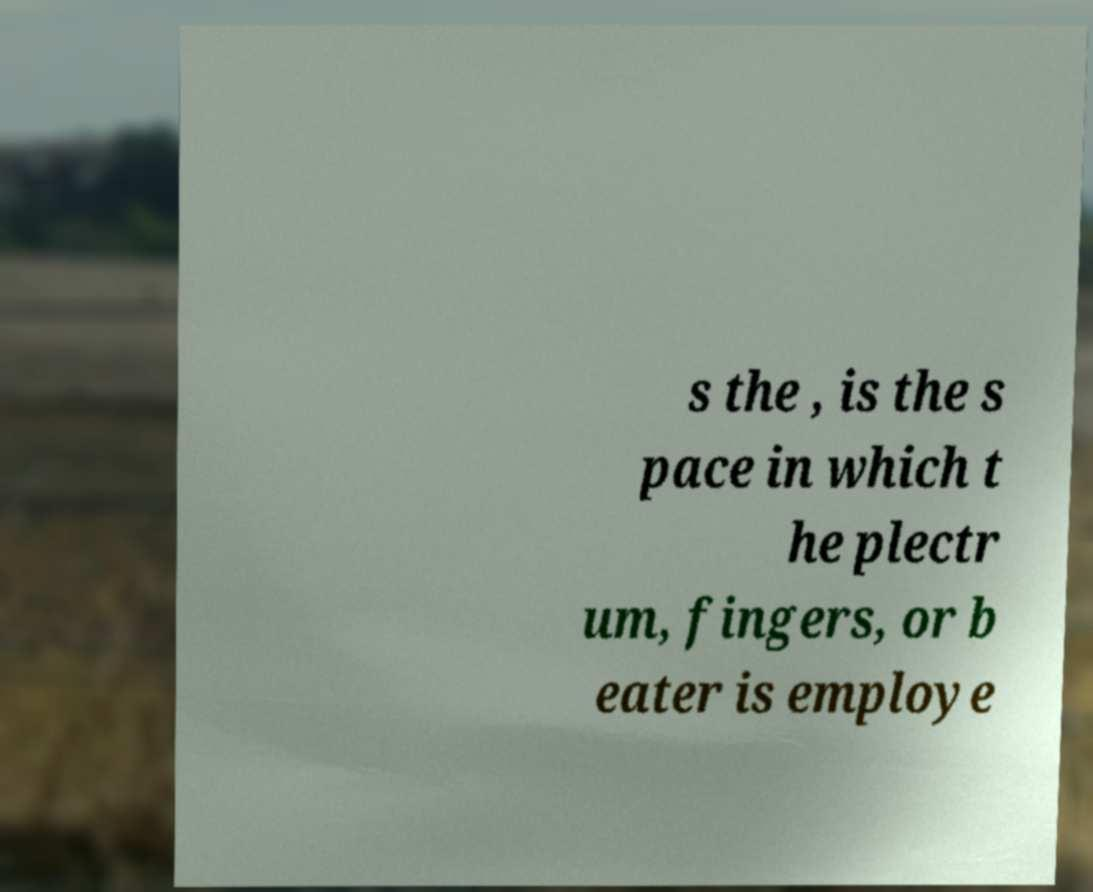Can you accurately transcribe the text from the provided image for me? s the , is the s pace in which t he plectr um, fingers, or b eater is employe 